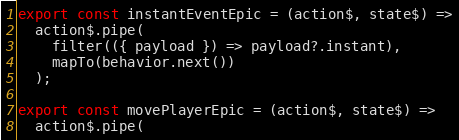Convert code to text. <code><loc_0><loc_0><loc_500><loc_500><_JavaScript_>
export const instantEventEpic = (action$, state$) =>
  action$.pipe(
    filter(({ payload }) => payload?.instant),
    mapTo(behavior.next())
  );

export const movePlayerEpic = (action$, state$) =>
  action$.pipe(</code> 